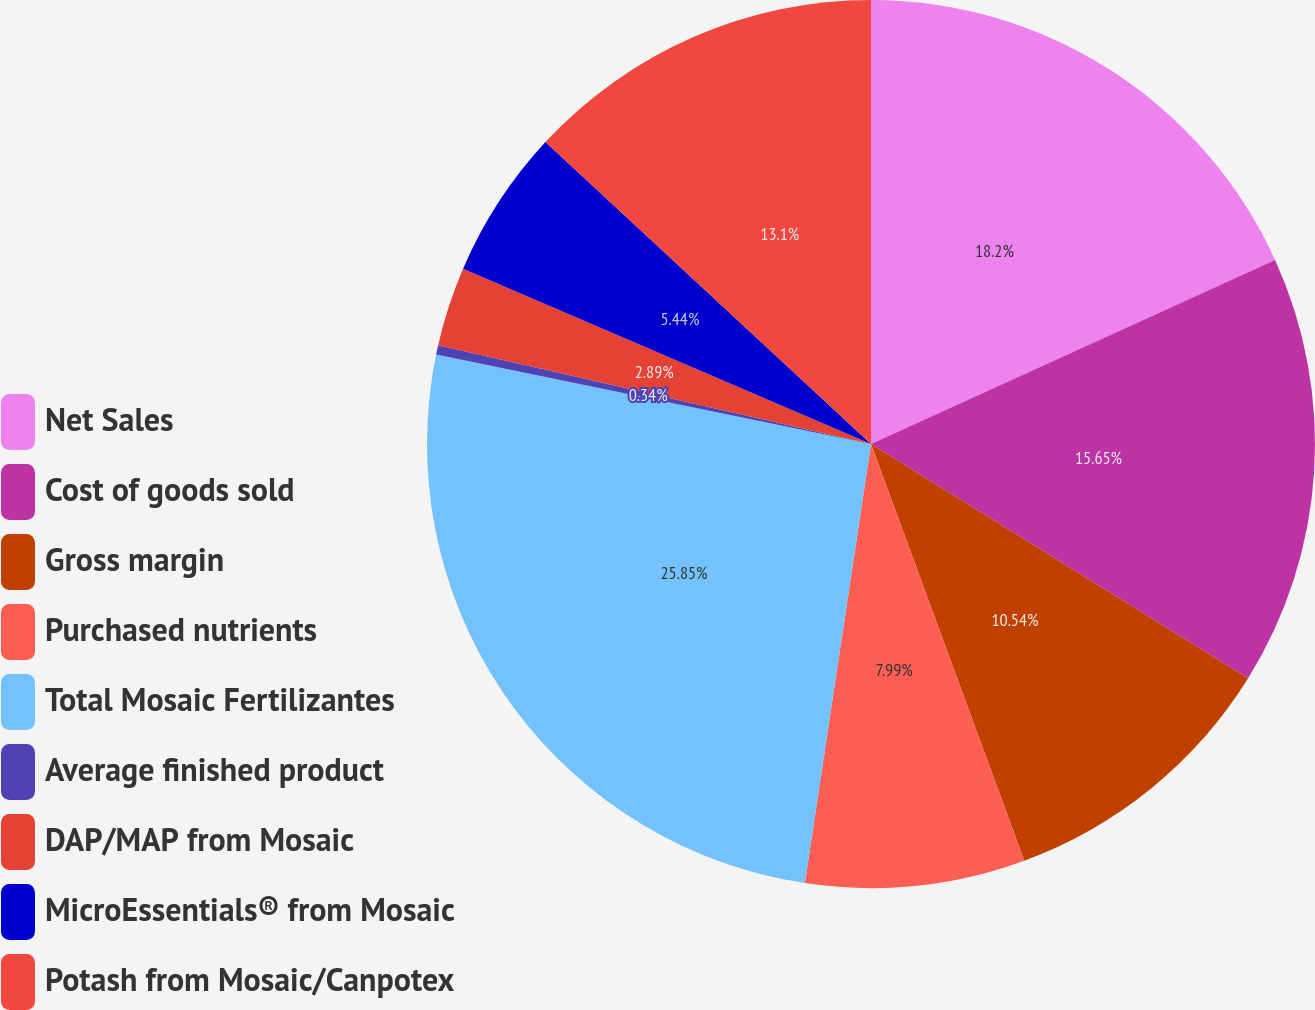Convert chart. <chart><loc_0><loc_0><loc_500><loc_500><pie_chart><fcel>Net Sales<fcel>Cost of goods sold<fcel>Gross margin<fcel>Purchased nutrients<fcel>Total Mosaic Fertilizantes<fcel>Average finished product<fcel>DAP/MAP from Mosaic<fcel>MicroEssentials® from Mosaic<fcel>Potash from Mosaic/Canpotex<nl><fcel>18.2%<fcel>15.65%<fcel>10.54%<fcel>7.99%<fcel>25.85%<fcel>0.34%<fcel>2.89%<fcel>5.44%<fcel>13.1%<nl></chart> 